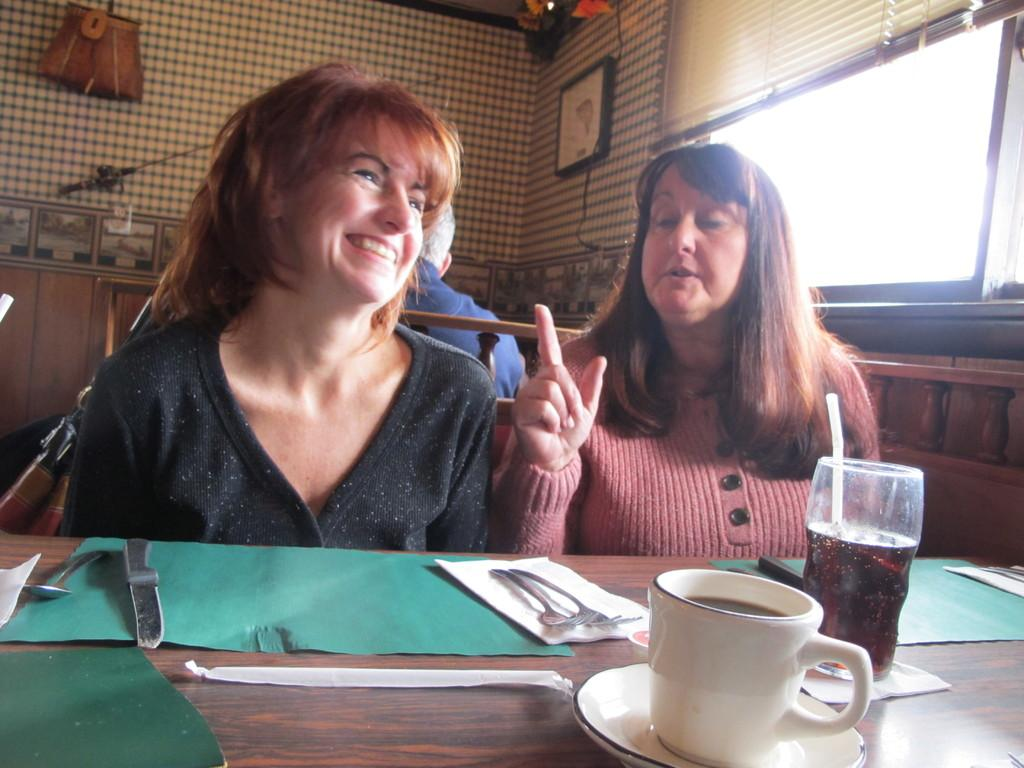What can be seen in the background of the image? There is a wall in the image. What are the people in the image doing? There are people sitting on benches in the image. What is on the table in the image? There is a cloth, a paper, forks, a glass, a cup, and a saucer on the table. What color are the lizards on the table in the image? There are no lizards present in the image. What type of cub is used to cut the paper on the table? There is no mention of a cub or cutting the paper in the image. 